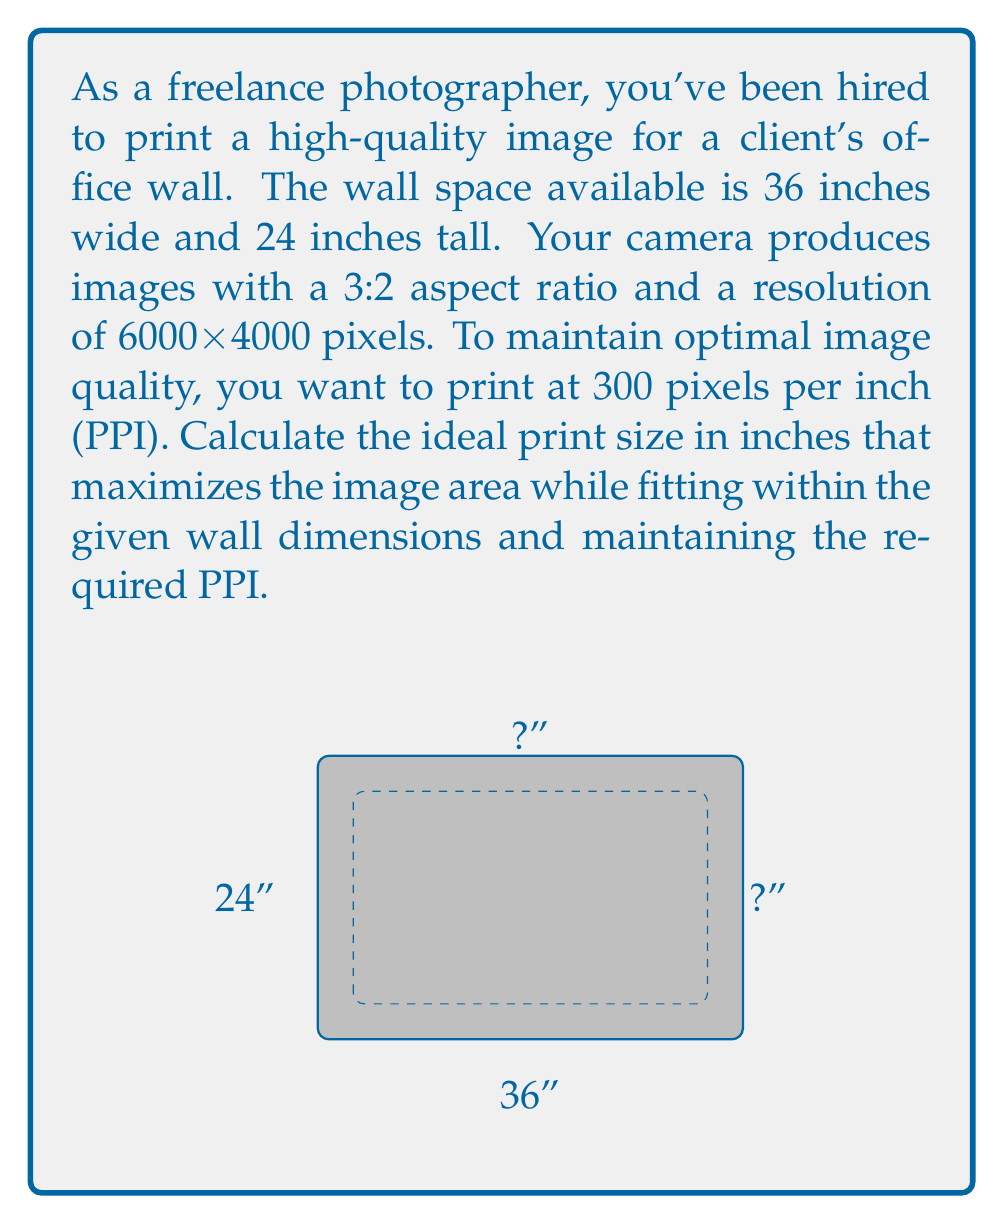Teach me how to tackle this problem. Let's approach this step-by-step:

1) First, we need to determine the aspect ratio of our print. The camera produces images with a 3:2 aspect ratio, so our print will maintain this ratio.

2) Let's define variables:
   $w$ = width of the print in inches
   $h$ = height of the print in inches

3) Given the aspect ratio, we can express height in terms of width:
   $h = \frac{2}{3}w$

4) We know that we want to print at 300 PPI. Given the image resolution:
   $\frac{6000 \text{ pixels}}{300 \text{ PPI}} = 20$ inches (max width)
   $\frac{4000 \text{ pixels}}{300 \text{ PPI}} = 13.33$ inches (max height)

5) Now, we need to fit this within the wall dimensions while maximizing the area. We have two constraints:
   $w \leq 36$ and $h \leq 24$

6) Substituting $h$ with $\frac{2}{3}w$ in the height constraint:
   $\frac{2}{3}w \leq 24$
   $w \leq 36$

7) The limiting factor is the height constraint:
   $\frac{2}{3}w \leq 24$
   $w \leq 36$

8) Solving for $w$:
   $w \leq 36$
   $w \leq 20$ (from step 4)
   $w \leq 24 \times \frac{3}{2} = 36$

9) The smallest of these upper bounds is 20 inches, so:
   $w = 20$ inches
   $h = \frac{2}{3} \times 20 = 13.33$ inches

Therefore, the ideal print size is 20 inches wide by 13.33 inches tall.
Answer: 20" × 13.33" 